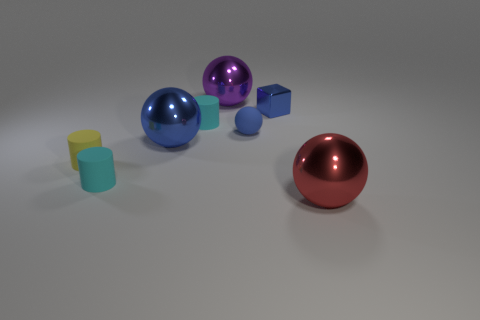Subtract all blue balls. How many were subtracted if there are1blue balls left? 1 Subtract all small cyan rubber cylinders. How many cylinders are left? 1 Add 1 matte things. How many objects exist? 9 Subtract all brown cylinders. How many blue spheres are left? 2 Subtract all yellow cylinders. How many cylinders are left? 2 Subtract 1 spheres. How many spheres are left? 3 Subtract all cylinders. How many objects are left? 5 Add 7 blue matte spheres. How many blue matte spheres exist? 8 Subtract 0 brown spheres. How many objects are left? 8 Subtract all yellow cubes. Subtract all purple cylinders. How many cubes are left? 1 